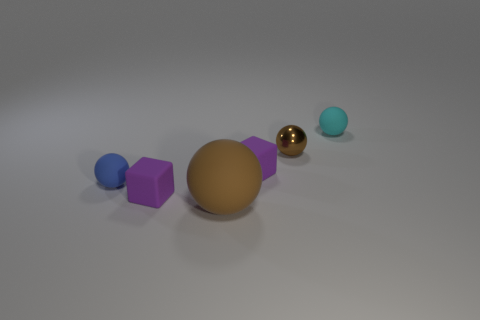The other large object that is the same color as the metallic thing is what shape?
Your response must be concise. Sphere. What is the color of the small matte object that is both on the right side of the brown matte thing and on the left side of the tiny brown ball?
Ensure brevity in your answer.  Purple. What number of things are matte cubes that are to the right of the large matte object or purple objects that are to the left of the small cyan matte sphere?
Offer a terse response. 2. The matte ball that is behind the small matte sphere that is to the left of the tiny rubber object on the right side of the metallic object is what color?
Offer a very short reply. Cyan. Are there any other big matte things that have the same shape as the large brown object?
Your answer should be compact. No. How many balls are there?
Offer a very short reply. 4. The blue object has what shape?
Offer a terse response. Sphere. What number of blue rubber spheres are the same size as the brown matte ball?
Make the answer very short. 0. Does the tiny blue object have the same shape as the large thing?
Offer a terse response. Yes. What color is the small thing in front of the small rubber ball that is to the left of the small cyan rubber ball?
Keep it short and to the point. Purple. 